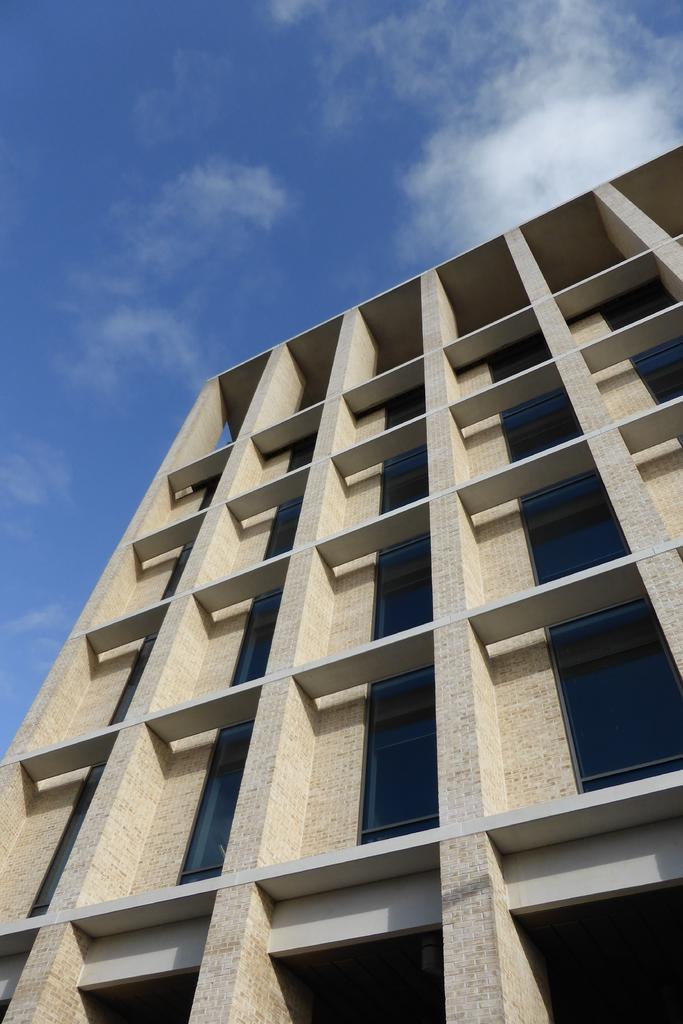What is the main structure in the image? There is a building in the image. What feature can be seen on the building? The building has windows with glasses. What can be seen in the sky in the image? There are clouds in the sky. Who is the creator of the stranger in the image? There is no stranger present in the image, so it is not possible to determine the creator. 